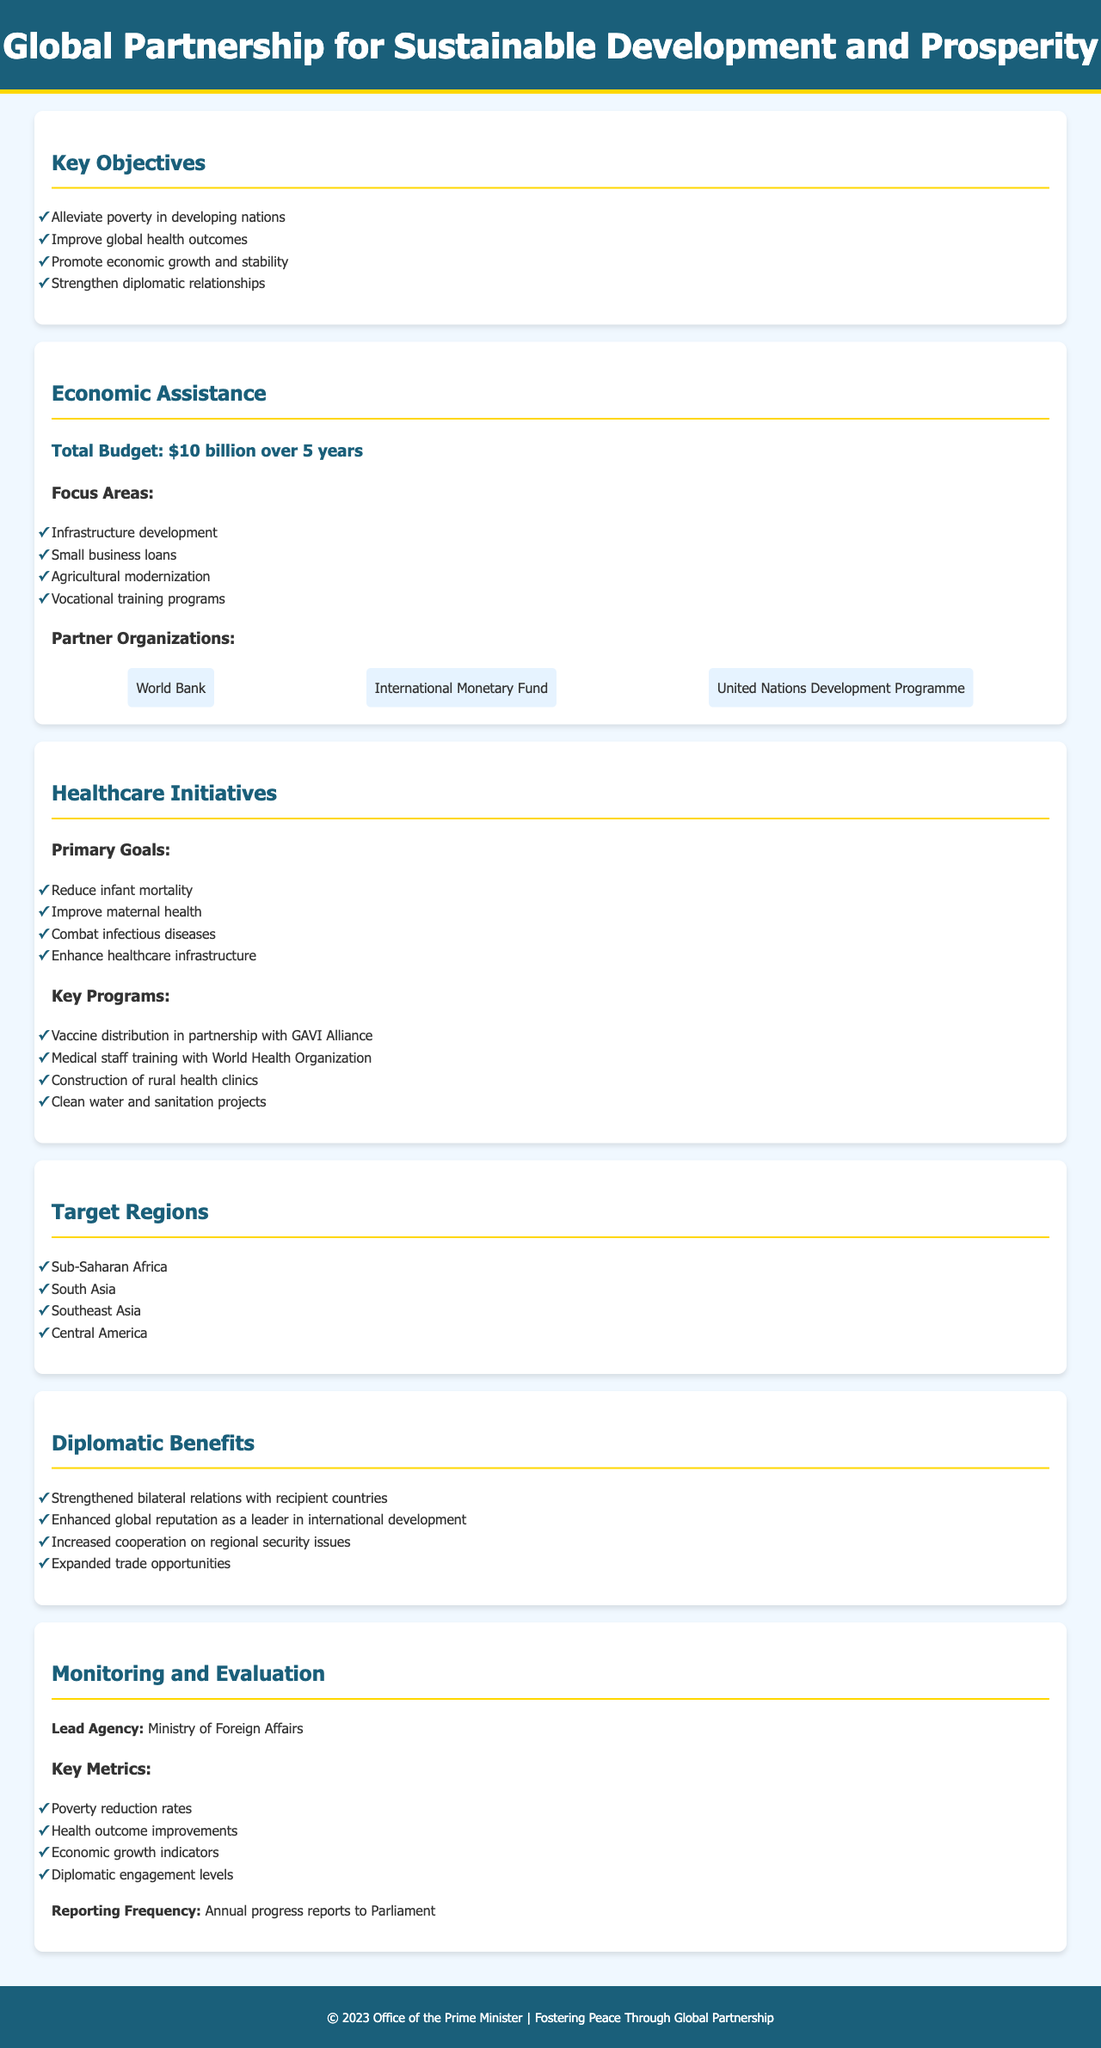What is the total budget for the economic assistance? The total budget for economic assistance is stated in the document as being $10 billion over 5 years.
Answer: $10 billion over 5 years What are the primary goals of the healthcare initiatives? The primary goals listed in the document include reducing infant mortality, improving maternal health, combating infectious diseases, and enhancing healthcare infrastructure.
Answer: Reduce infant mortality, improve maternal health, combat infectious diseases, enhance healthcare infrastructure Which regions are targeted by this foreign aid package? The document specifies four target regions: Sub-Saharan Africa, South Asia, Southeast Asia, and Central America.
Answer: Sub-Saharan Africa, South Asia, Southeast Asia, Central America Who are the partner organizations involved in economic assistance? The document lists three partner organizations: World Bank, International Monetary Fund, and United Nations Development Programme.
Answer: World Bank, International Monetary Fund, United Nations Development Programme What is the lead agency for monitoring and evaluation? The document identifies the Ministry of Foreign Affairs as the lead agency responsible for monitoring and evaluation.
Answer: Ministry of Foreign Affairs What is one of the diplomatic benefits mentioned in the document? The document lists several benefits, one of which is strengthened bilateral relations with recipient countries.
Answer: Strengthened bilateral relations with recipient countries What metrics are used for monitoring progress? The document states that key metrics include poverty reduction rates, health outcome improvements, economic growth indicators, and diplomatic engagement levels.
Answer: Poverty reduction rates, health outcome improvements, economic growth indicators, diplomatic engagement levels How frequently will progress reports be submitted? According to the document, annual progress reports will be made to Parliament, indicating the frequency of reporting.
Answer: Annual progress reports to Parliament 